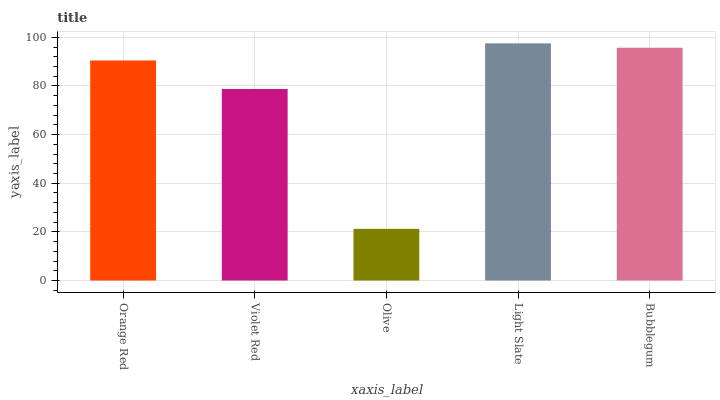Is Olive the minimum?
Answer yes or no. Yes. Is Light Slate the maximum?
Answer yes or no. Yes. Is Violet Red the minimum?
Answer yes or no. No. Is Violet Red the maximum?
Answer yes or no. No. Is Orange Red greater than Violet Red?
Answer yes or no. Yes. Is Violet Red less than Orange Red?
Answer yes or no. Yes. Is Violet Red greater than Orange Red?
Answer yes or no. No. Is Orange Red less than Violet Red?
Answer yes or no. No. Is Orange Red the high median?
Answer yes or no. Yes. Is Orange Red the low median?
Answer yes or no. Yes. Is Violet Red the high median?
Answer yes or no. No. Is Light Slate the low median?
Answer yes or no. No. 